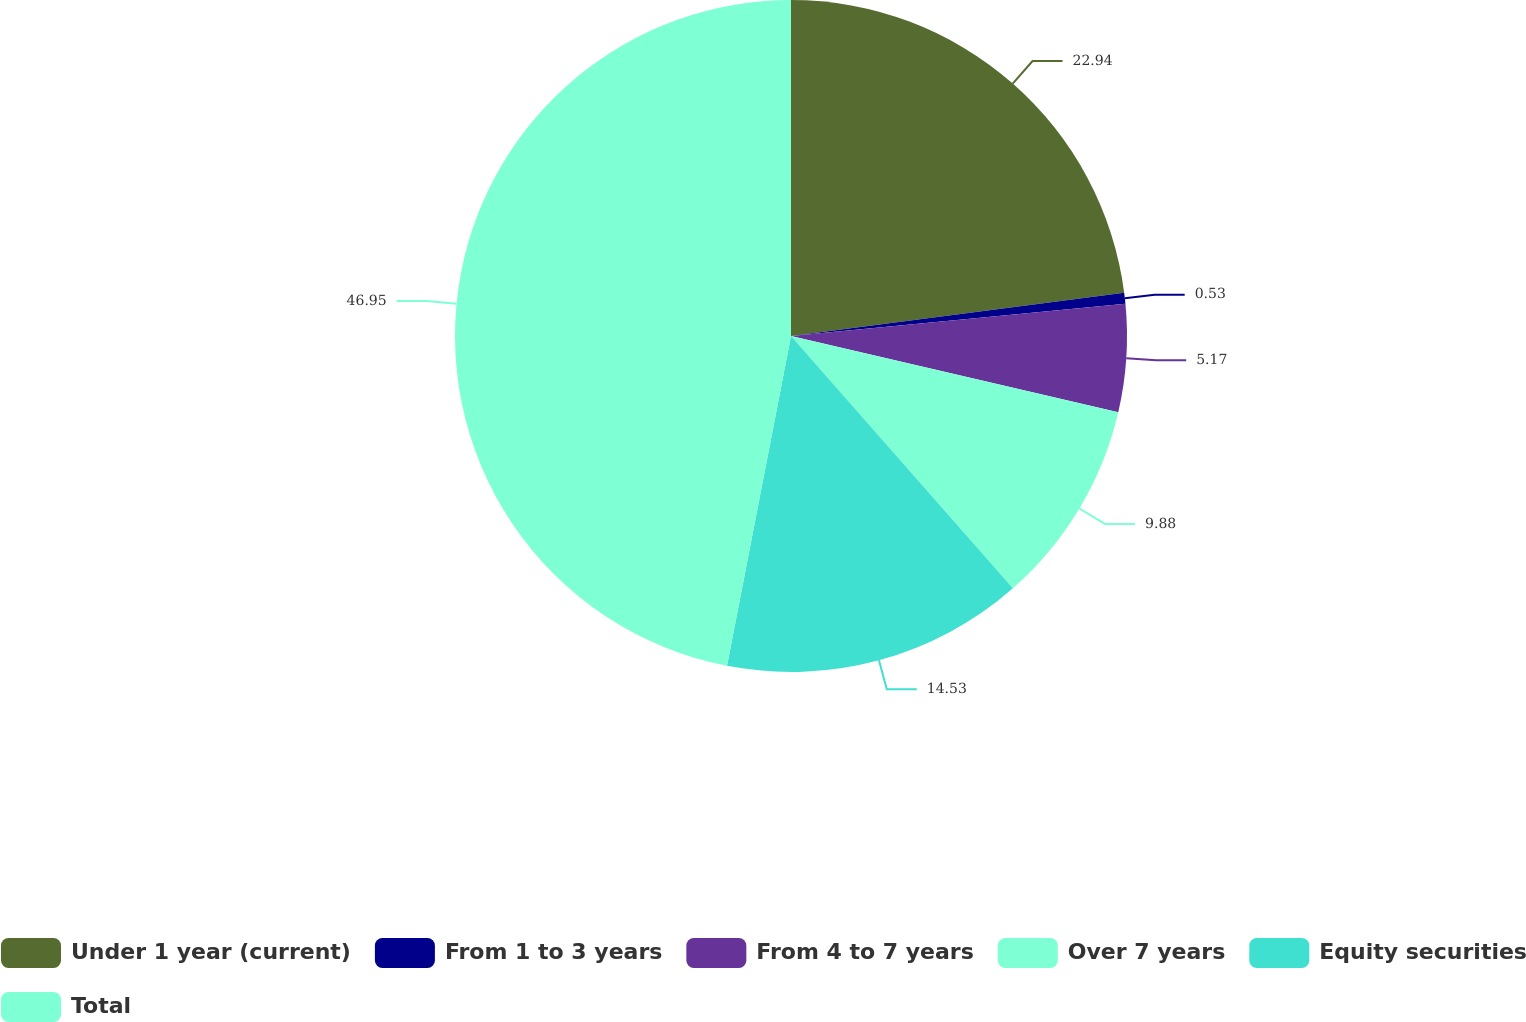<chart> <loc_0><loc_0><loc_500><loc_500><pie_chart><fcel>Under 1 year (current)<fcel>From 1 to 3 years<fcel>From 4 to 7 years<fcel>Over 7 years<fcel>Equity securities<fcel>Total<nl><fcel>22.94%<fcel>0.53%<fcel>5.17%<fcel>9.88%<fcel>14.53%<fcel>46.95%<nl></chart> 